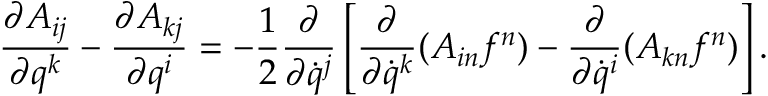<formula> <loc_0><loc_0><loc_500><loc_500>\frac { \partial A _ { i j } } { \partial q ^ { k } } - \frac { \partial A _ { k j } } { \partial q ^ { i } } = - \frac { 1 } { 2 } \frac { \partial } { \partial \dot { q } ^ { j } } \left [ \frac { \partial } { \partial \dot { q } ^ { k } } ( A _ { i n } f ^ { n } ) - \frac { \partial } { \partial \dot { q } ^ { i } } ( A _ { k n } f ^ { n } ) \right ] .</formula> 